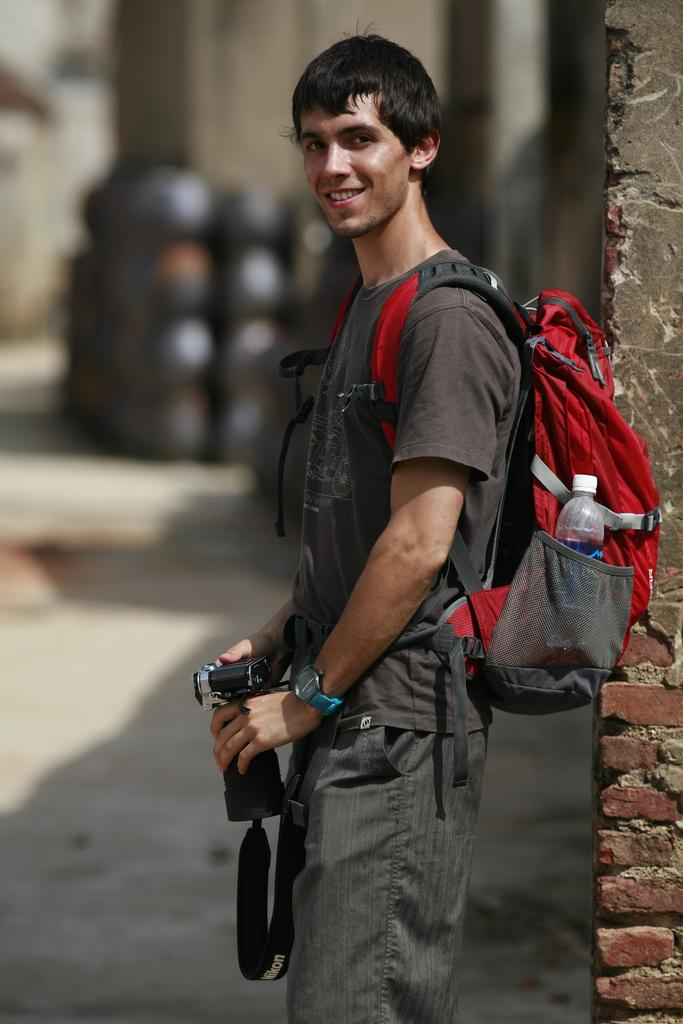Who is present in the image? There is a person in the image. What is the person doing in the image? The person is standing and smiling. What is the person wearing in the image? The person is wearing a bag. What is the person holding in the image? The person is holding a camera. How many icicles are hanging from the person's ear in the image? There are no icicles present in the image, and the person's ear is not visible. 